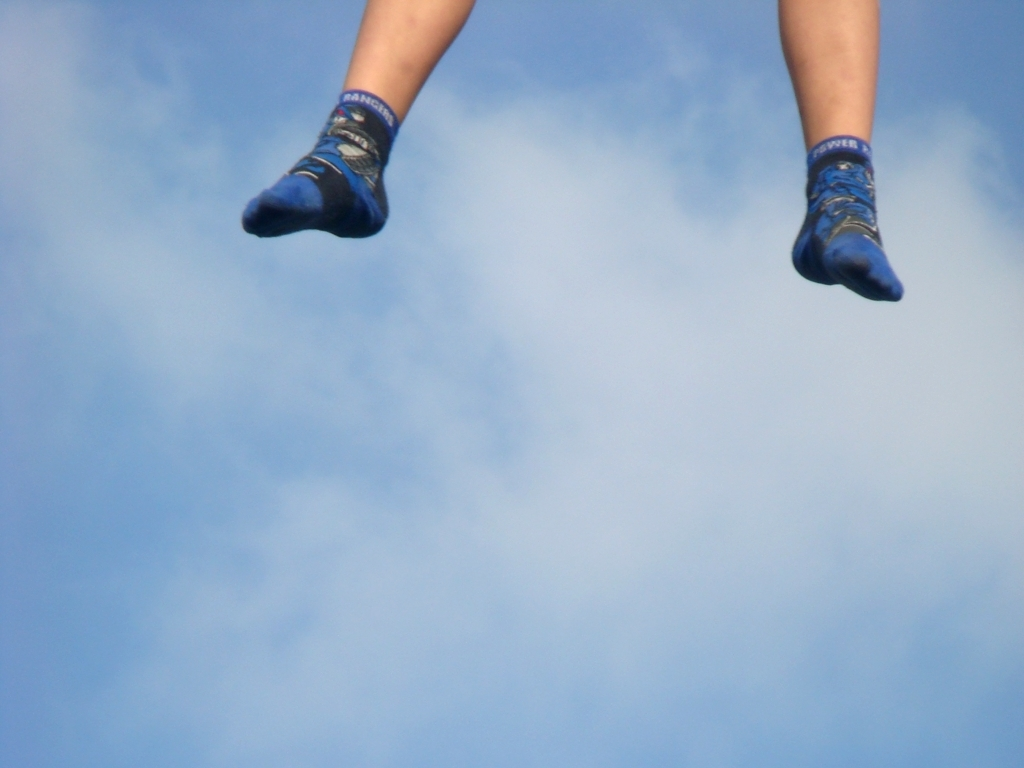Without seeing the rest of the scene, what might the weather be like? The background of the image shows a clear blue sky, which is often indicative of good weather conditions, likely sunny with minimal cloud coverage. The visibility and brightness in the photograph suggest it's taken during daytime with favorable outdoor conditions. 